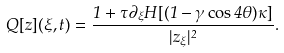<formula> <loc_0><loc_0><loc_500><loc_500>Q [ z ] ( \xi , t ) = \frac { 1 + \tau \partial _ { \xi } H [ ( 1 - \gamma \cos 4 \theta ) \kappa ] } { | z _ { \xi } | ^ { 2 } } .</formula> 